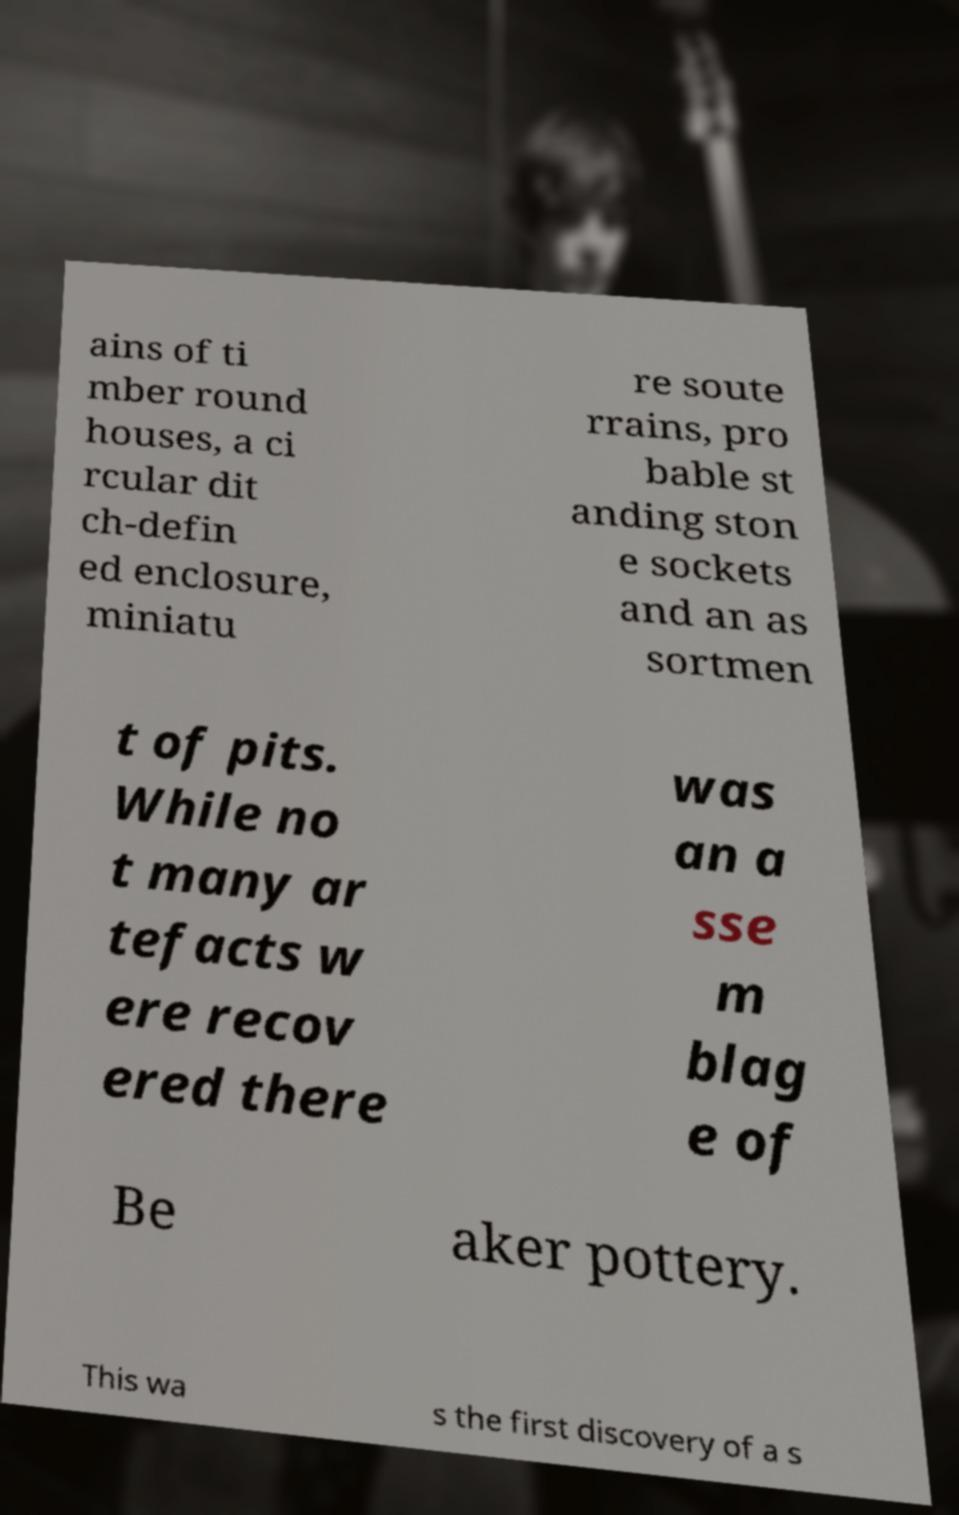There's text embedded in this image that I need extracted. Can you transcribe it verbatim? ains of ti mber round houses, a ci rcular dit ch-defin ed enclosure, miniatu re soute rrains, pro bable st anding ston e sockets and an as sortmen t of pits. While no t many ar tefacts w ere recov ered there was an a sse m blag e of Be aker pottery. This wa s the first discovery of a s 